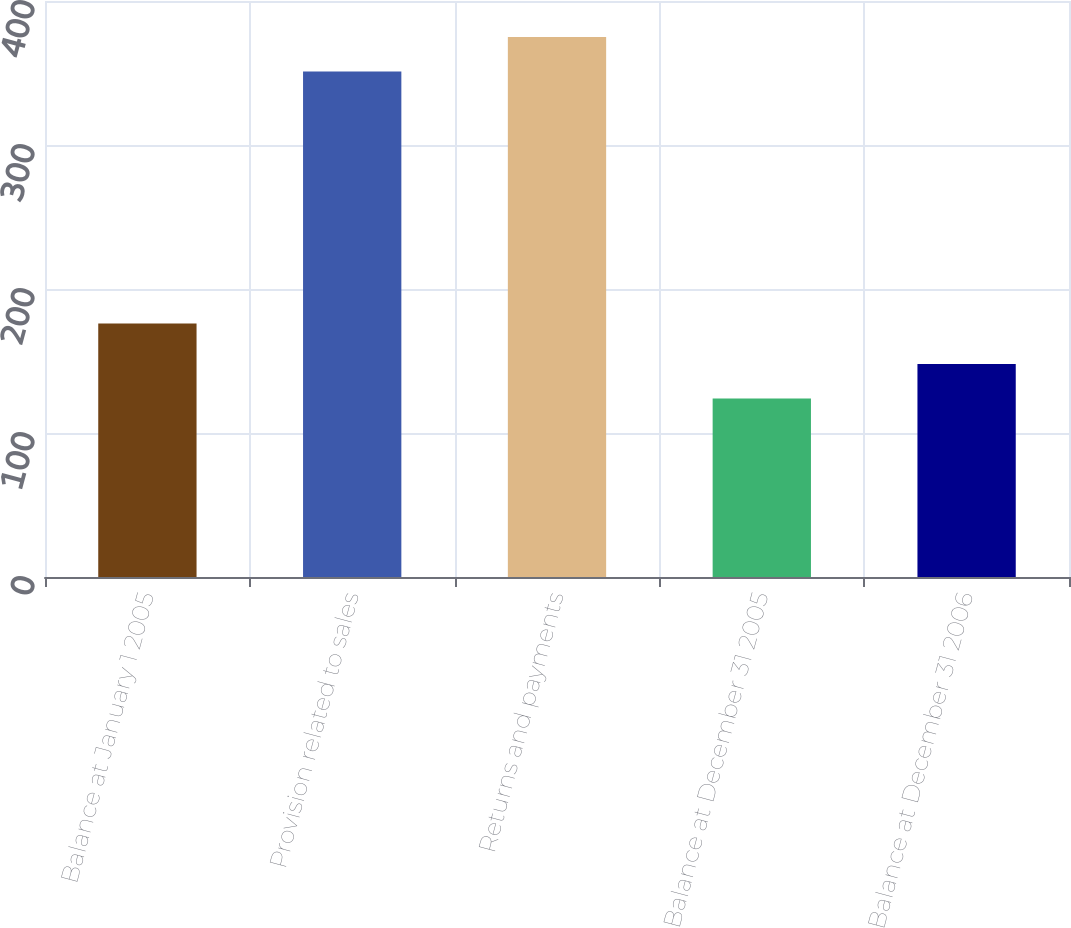Convert chart. <chart><loc_0><loc_0><loc_500><loc_500><bar_chart><fcel>Balance at January 1 2005<fcel>Provision related to sales<fcel>Returns and payments<fcel>Balance at December 31 2005<fcel>Balance at December 31 2006<nl><fcel>176<fcel>351<fcel>375<fcel>124<fcel>148<nl></chart> 